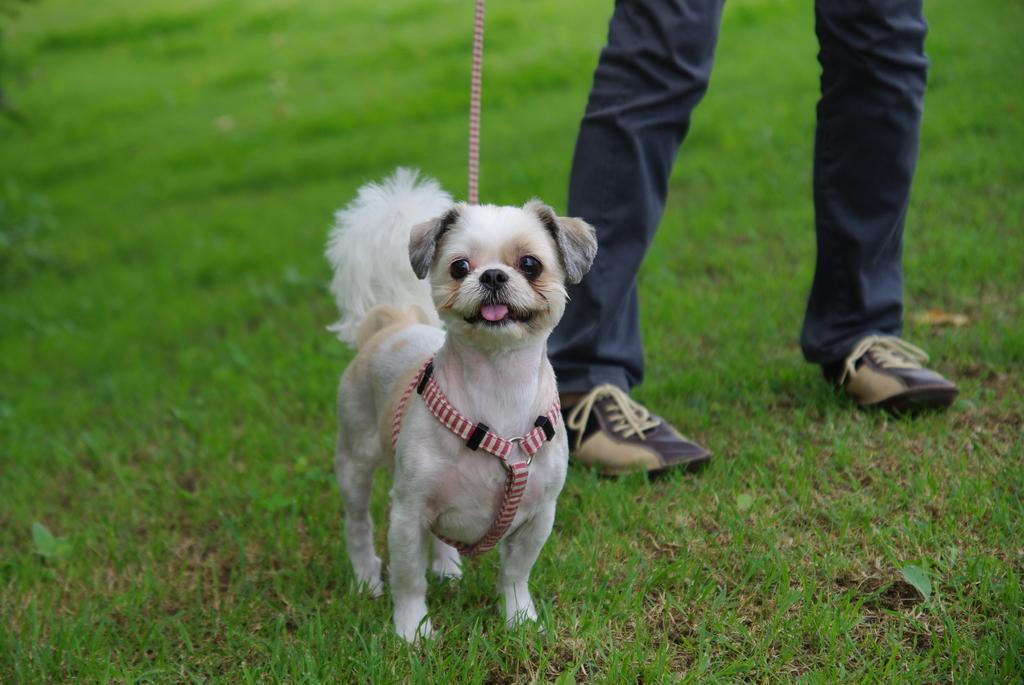How would you summarize this image in a sentence or two? In this picture, we see a white dog. The leash of the dog is in pink color. At the bottom, we see the grass. On the right side, we see the legs of the person who is standing. The person is wearing the grey pant and the shoes. In the background, it is green in color and this picture is blurred in the background. 